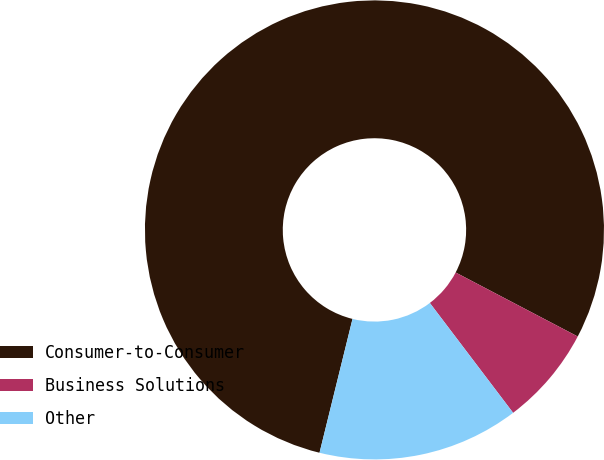Convert chart. <chart><loc_0><loc_0><loc_500><loc_500><pie_chart><fcel>Consumer-to-Consumer<fcel>Business Solutions<fcel>Other<nl><fcel>78.84%<fcel>6.99%<fcel>14.17%<nl></chart> 